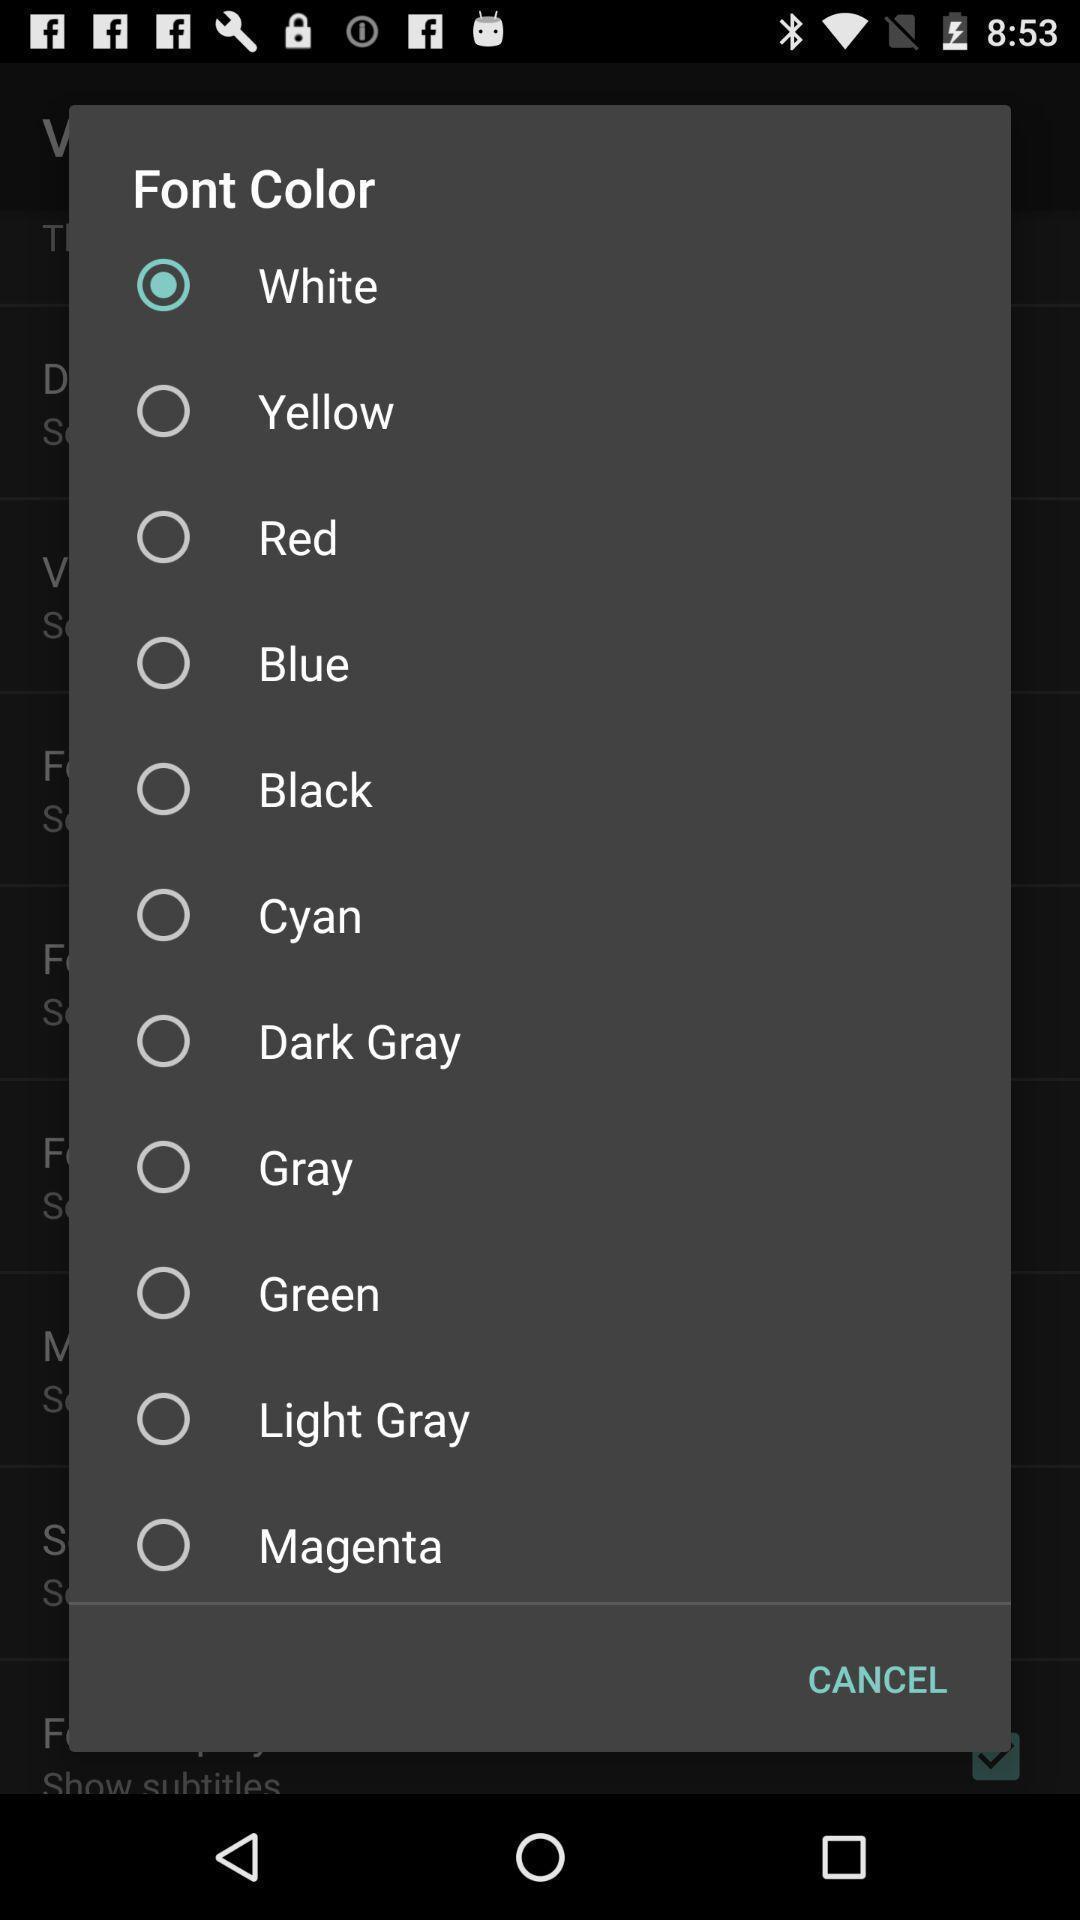Summarize the main components in this picture. Popup showing list of font colors. 